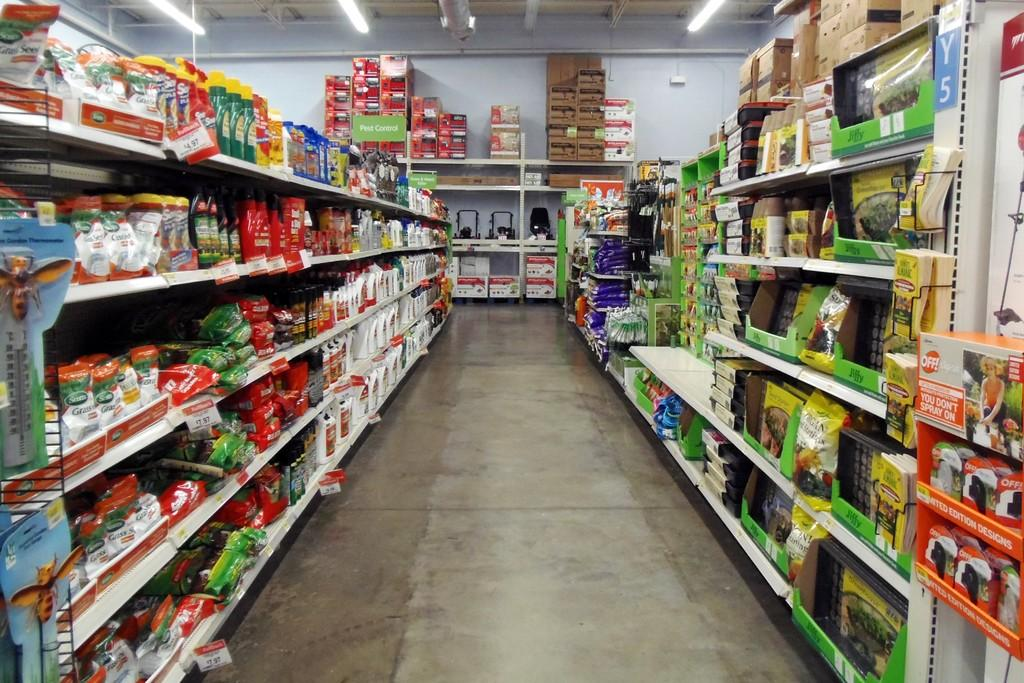Provide a one-sentence caption for the provided image. a supermarket aisle with a tag reading 14.97. 